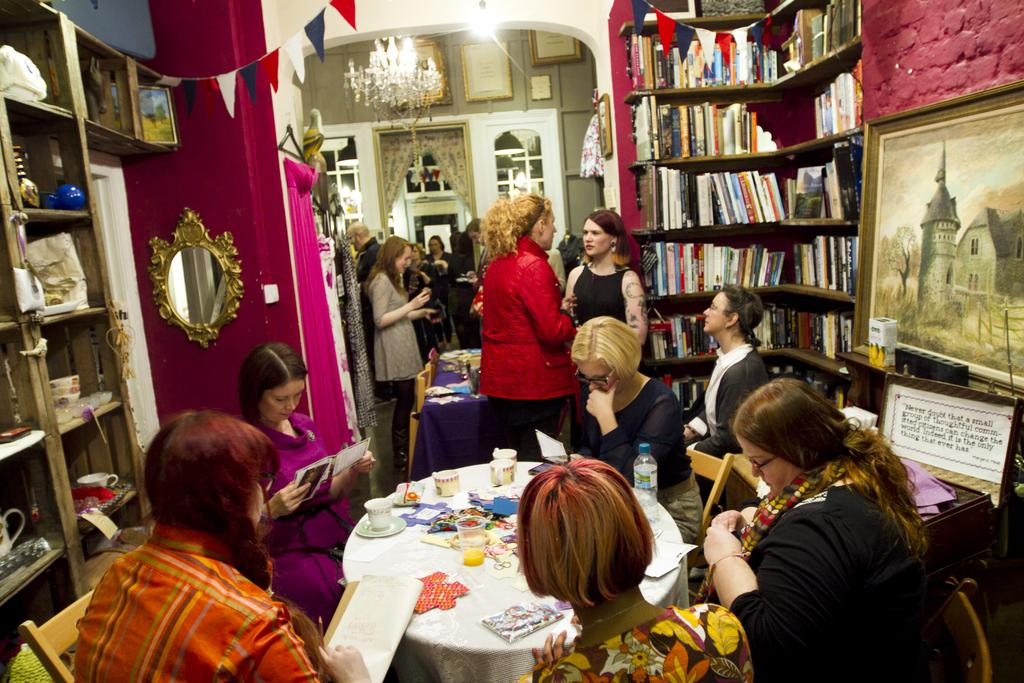What are the women in the foreground of the image doing? The women in the foreground of the image are sitting on chairs and reading something. Can you describe the women in the background of the image? The women in the background of the image are standing. What can be seen in the image that might be related to reading? There is a bookshelf in the image. What type of story can be heard being told by the bag in the image? There is no bag present in the image, and therefore no story can be heard being told by it. 